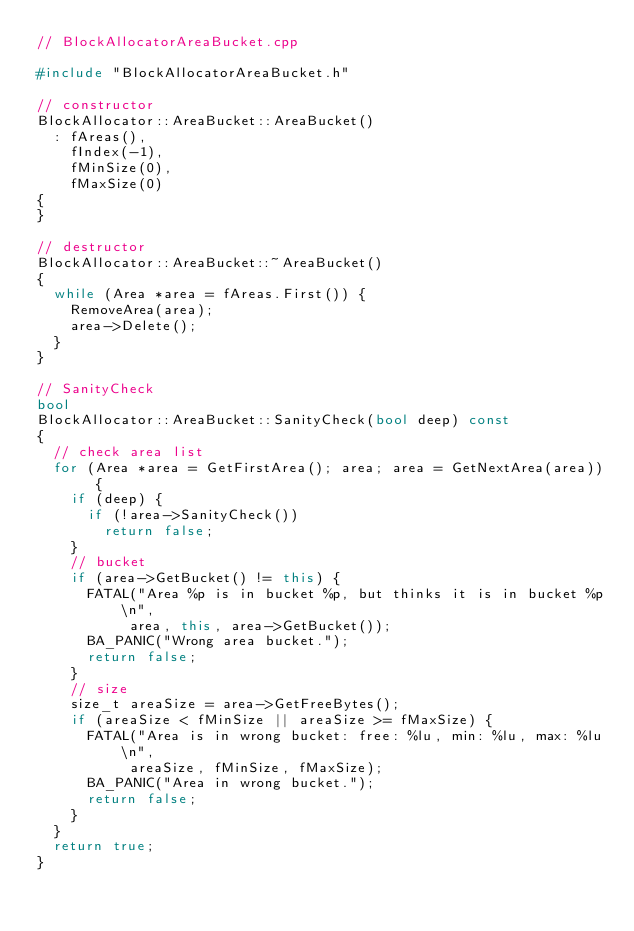<code> <loc_0><loc_0><loc_500><loc_500><_C++_>// BlockAllocatorAreaBucket.cpp

#include "BlockAllocatorAreaBucket.h"

// constructor
BlockAllocator::AreaBucket::AreaBucket()
	: fAreas(),
	  fIndex(-1),
	  fMinSize(0),
	  fMaxSize(0)
{
}

// destructor
BlockAllocator::AreaBucket::~AreaBucket()
{
	while (Area *area = fAreas.First()) {
		RemoveArea(area);
		area->Delete();
	}
}

// SanityCheck
bool
BlockAllocator::AreaBucket::SanityCheck(bool deep) const
{
	// check area list
	for (Area *area = GetFirstArea(); area; area = GetNextArea(area)) {
		if (deep) {
			if (!area->SanityCheck())
				return false;
		}
		// bucket
		if (area->GetBucket() != this) {
			FATAL("Area %p is in bucket %p, but thinks it is in bucket %p\n",
				   area, this, area->GetBucket());
			BA_PANIC("Wrong area bucket.");
			return false;
		}
		// size
		size_t areaSize = area->GetFreeBytes();
		if (areaSize < fMinSize || areaSize >= fMaxSize) {
			FATAL("Area is in wrong bucket: free: %lu, min: %lu, max: %lu\n",
				   areaSize, fMinSize, fMaxSize);
			BA_PANIC("Area in wrong bucket.");
			return false;
		}
	}
	return true;
}

</code> 